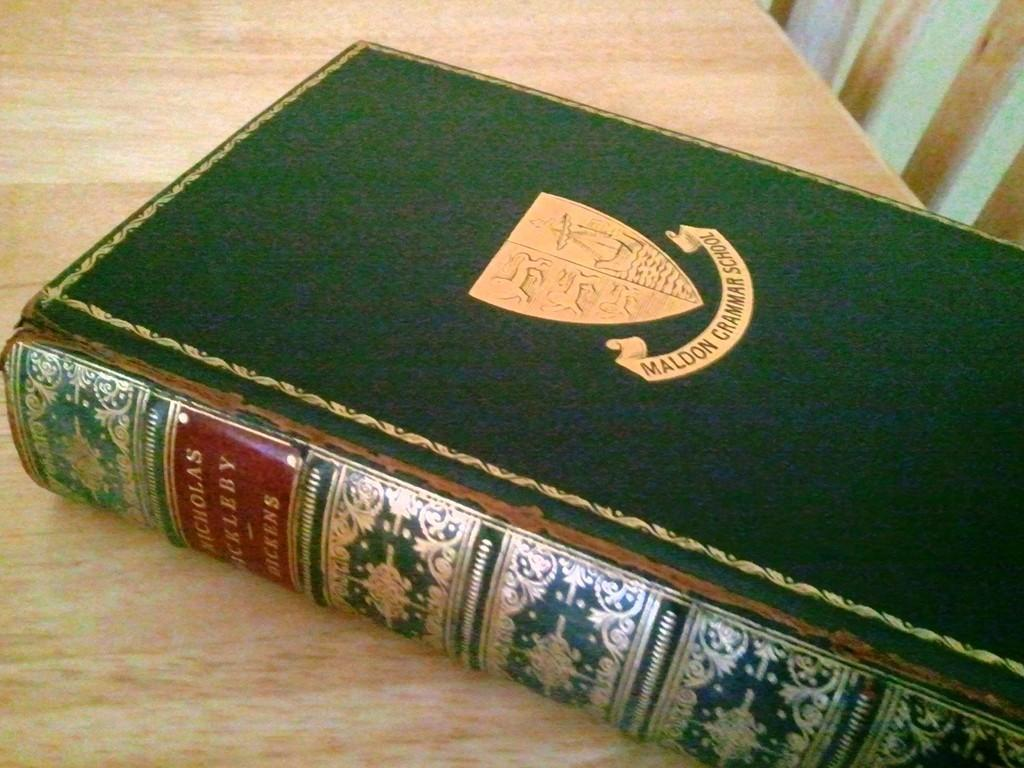<image>
Relay a brief, clear account of the picture shown. A book with a shield on the cover is from Maldon Grammar School. 